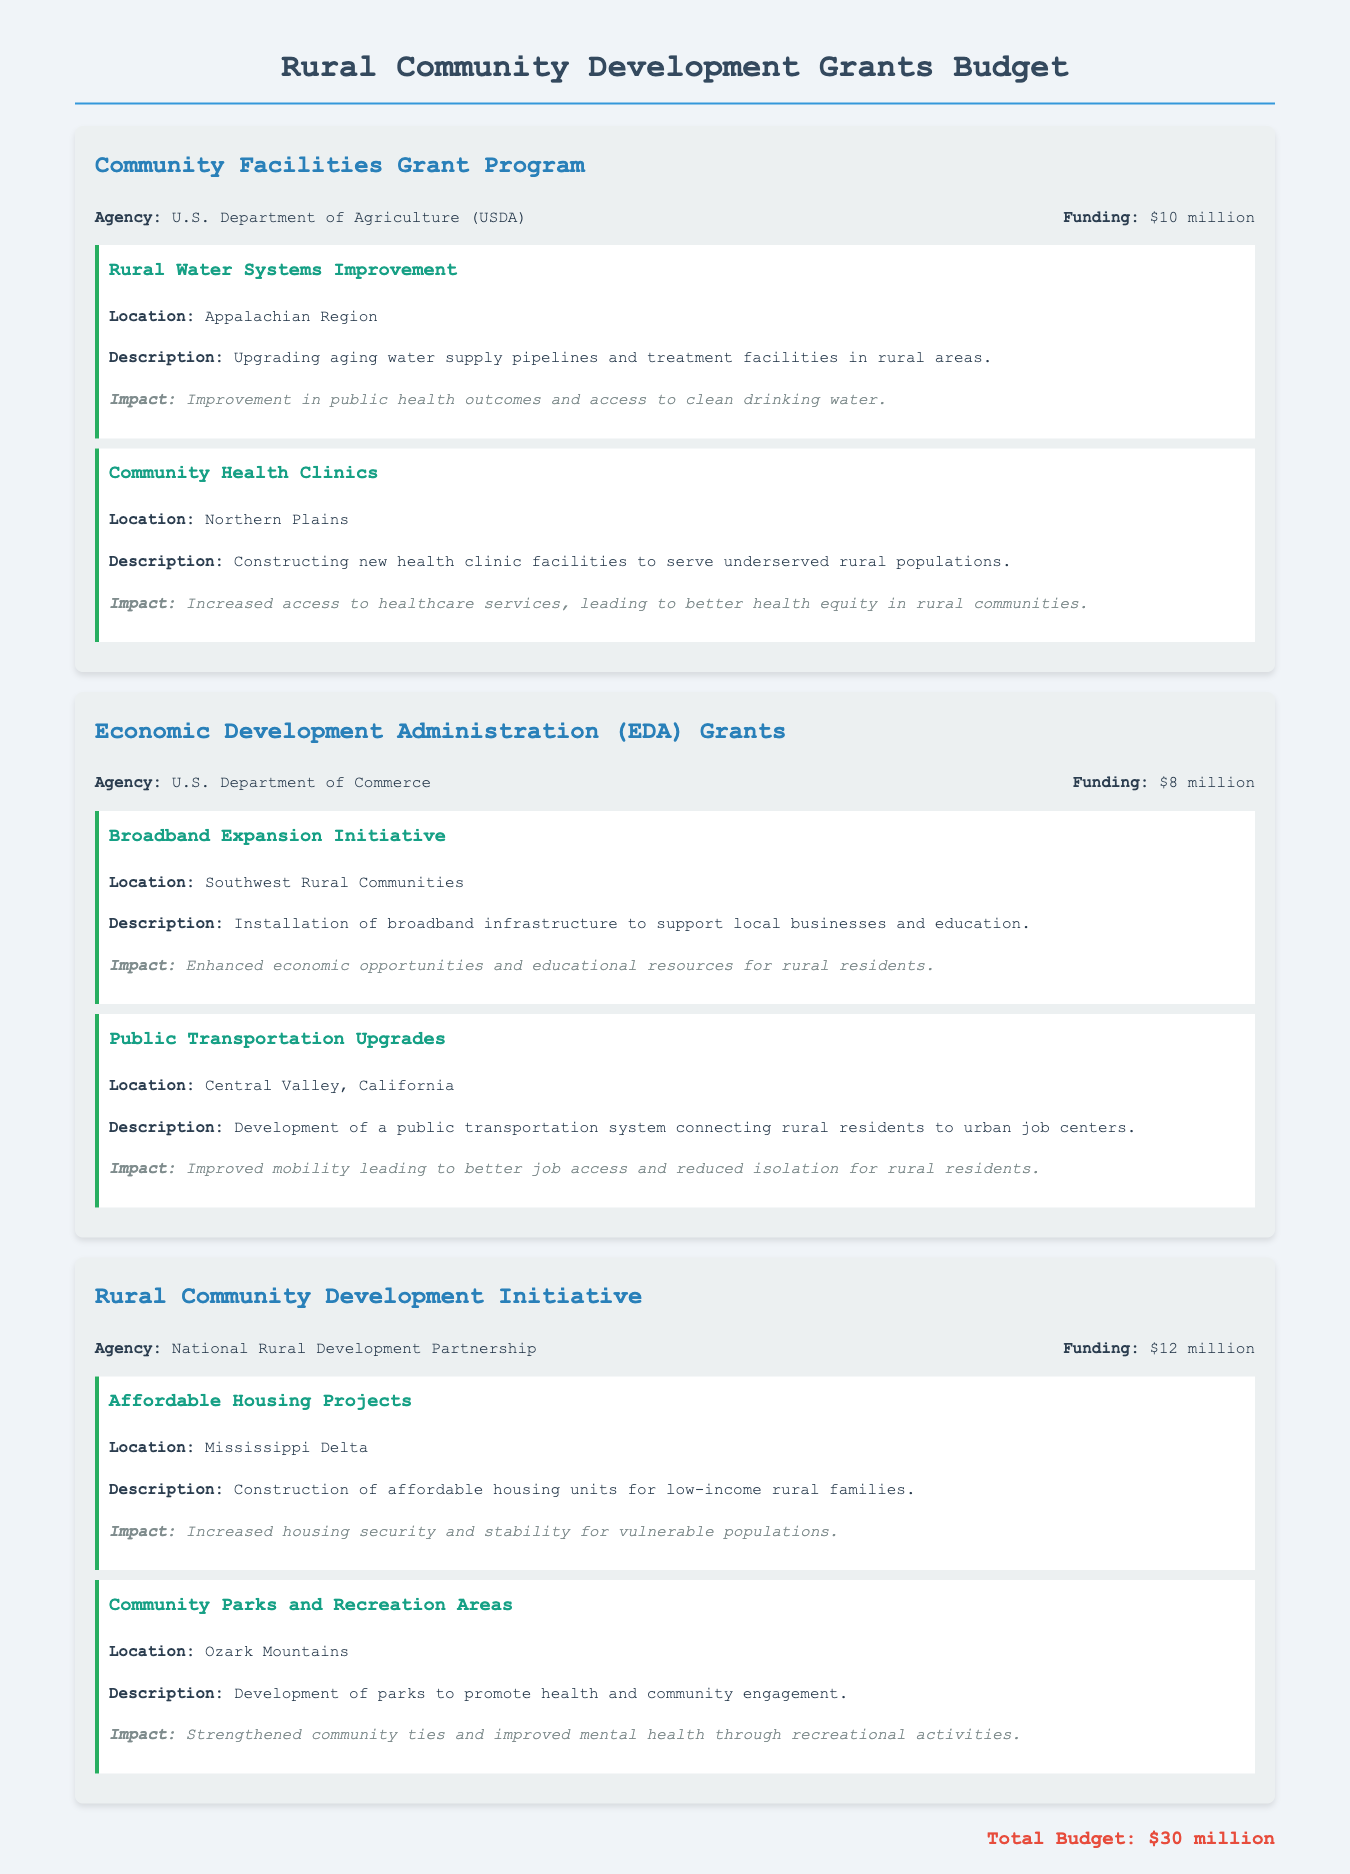What is the total funding for the Community Facilities Grant Program? The total funding for the Community Facilities Grant Program is stated as $10 million in the document.
Answer: $10 million What project is located in the Appalachian Region? The document mentions the Rural Water Systems Improvement project as being in the Appalachian Region.
Answer: Rural Water Systems Improvement Which agency is responsible for the Economic Development Administration Grants? The agency responsible for the Economic Development Administration Grants is specified as the U.S. Department of Commerce.
Answer: U.S. Department of Commerce What is one anticipated impact of the Broadband Expansion Initiative? The document states that one anticipated impact of the Broadband Expansion Initiative is enhanced economic opportunities for rural residents.
Answer: Enhanced economic opportunities How much funding is allocated to the Rural Community Development Initiative? The document specifies that the funding allocated to the Rural Community Development Initiative is $12 million.
Answer: $12 million What type of projects does the Rural Community Development Initiative fund? The projects funded by the Rural Community Development Initiative include affordable housing and community parks.
Answer: Affordable housing and community parks What is the impact of constructing new health clinic facilities in rural areas? The document notes that the impact of constructing new health clinic facilities is increased access to healthcare services.
Answer: Increased access to healthcare services Which region is home to the Affordable Housing Projects? The document specifies that the Affordable Housing Projects are located in the Mississippi Delta region.
Answer: Mississippi Delta What is the total budget for all the grants listed in the document? The total budget for all the grants is clearly stated as $30 million in the document.
Answer: $30 million 